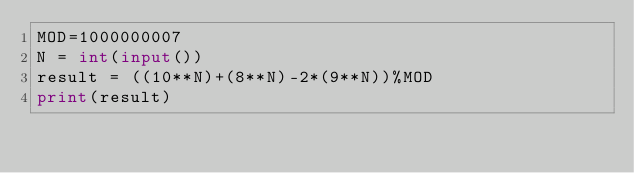<code> <loc_0><loc_0><loc_500><loc_500><_Python_>MOD=1000000007
N = int(input())
result = ((10**N)+(8**N)-2*(9**N))%MOD
print(result)</code> 